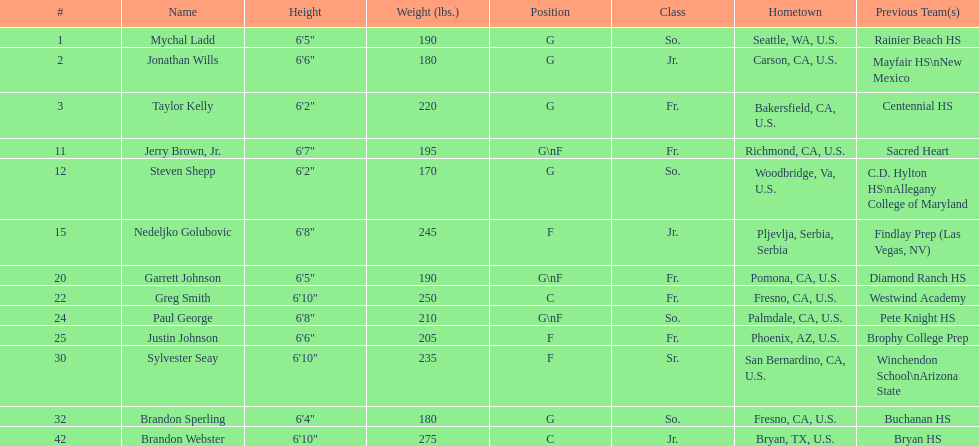Who is another player with a height of less than 6' 3", similar to taylor kelly? Steven Shepp. 